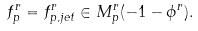Convert formula to latex. <formula><loc_0><loc_0><loc_500><loc_500>f ^ { r } _ { p } = f ^ { r } _ { p , j e t } \in M ^ { r } _ { p } ( - 1 - \phi ^ { r } ) .</formula> 